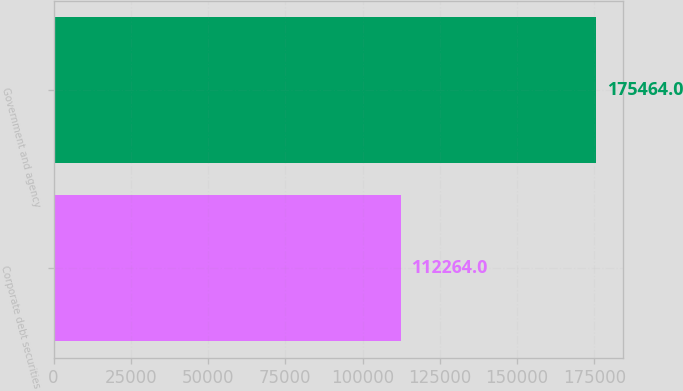<chart> <loc_0><loc_0><loc_500><loc_500><bar_chart><fcel>Corporate debt securities<fcel>Government and agency<nl><fcel>112264<fcel>175464<nl></chart> 